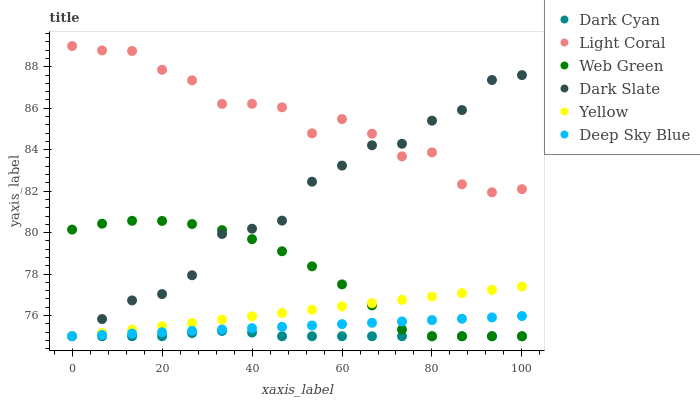Does Dark Cyan have the minimum area under the curve?
Answer yes or no. Yes. Does Light Coral have the maximum area under the curve?
Answer yes or no. Yes. Does Dark Slate have the minimum area under the curve?
Answer yes or no. No. Does Dark Slate have the maximum area under the curve?
Answer yes or no. No. Is Yellow the smoothest?
Answer yes or no. Yes. Is Light Coral the roughest?
Answer yes or no. Yes. Is Dark Slate the smoothest?
Answer yes or no. No. Is Dark Slate the roughest?
Answer yes or no. No. Does Yellow have the lowest value?
Answer yes or no. Yes. Does Light Coral have the lowest value?
Answer yes or no. No. Does Light Coral have the highest value?
Answer yes or no. Yes. Does Dark Slate have the highest value?
Answer yes or no. No. Is Web Green less than Light Coral?
Answer yes or no. Yes. Is Light Coral greater than Deep Sky Blue?
Answer yes or no. Yes. Does Web Green intersect Dark Slate?
Answer yes or no. Yes. Is Web Green less than Dark Slate?
Answer yes or no. No. Is Web Green greater than Dark Slate?
Answer yes or no. No. Does Web Green intersect Light Coral?
Answer yes or no. No. 